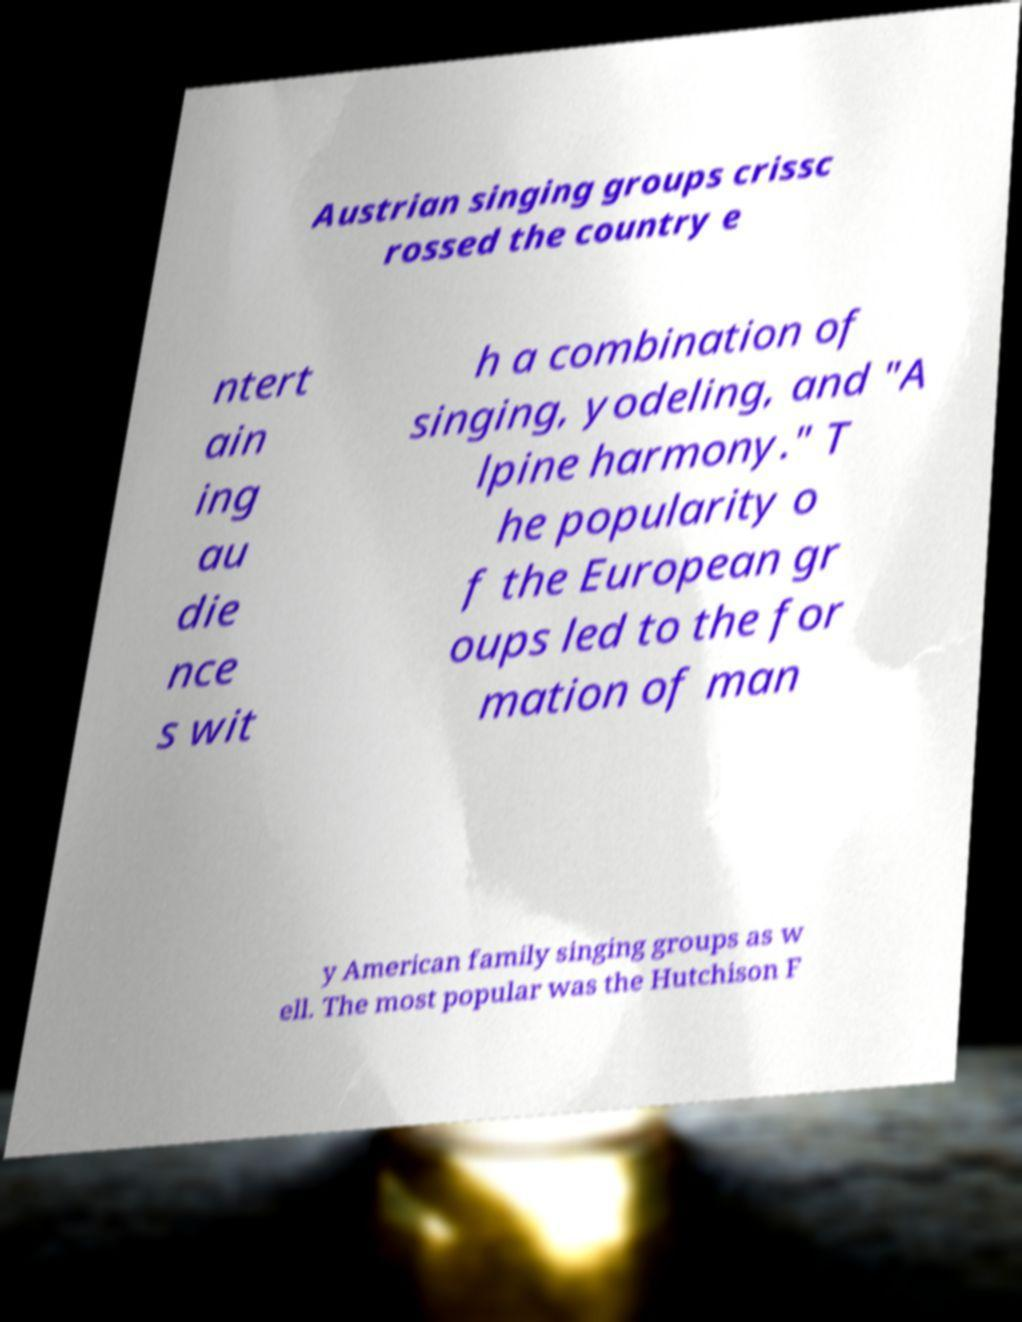For documentation purposes, I need the text within this image transcribed. Could you provide that? Austrian singing groups crissc rossed the country e ntert ain ing au die nce s wit h a combination of singing, yodeling, and "A lpine harmony." T he popularity o f the European gr oups led to the for mation of man y American family singing groups as w ell. The most popular was the Hutchison F 